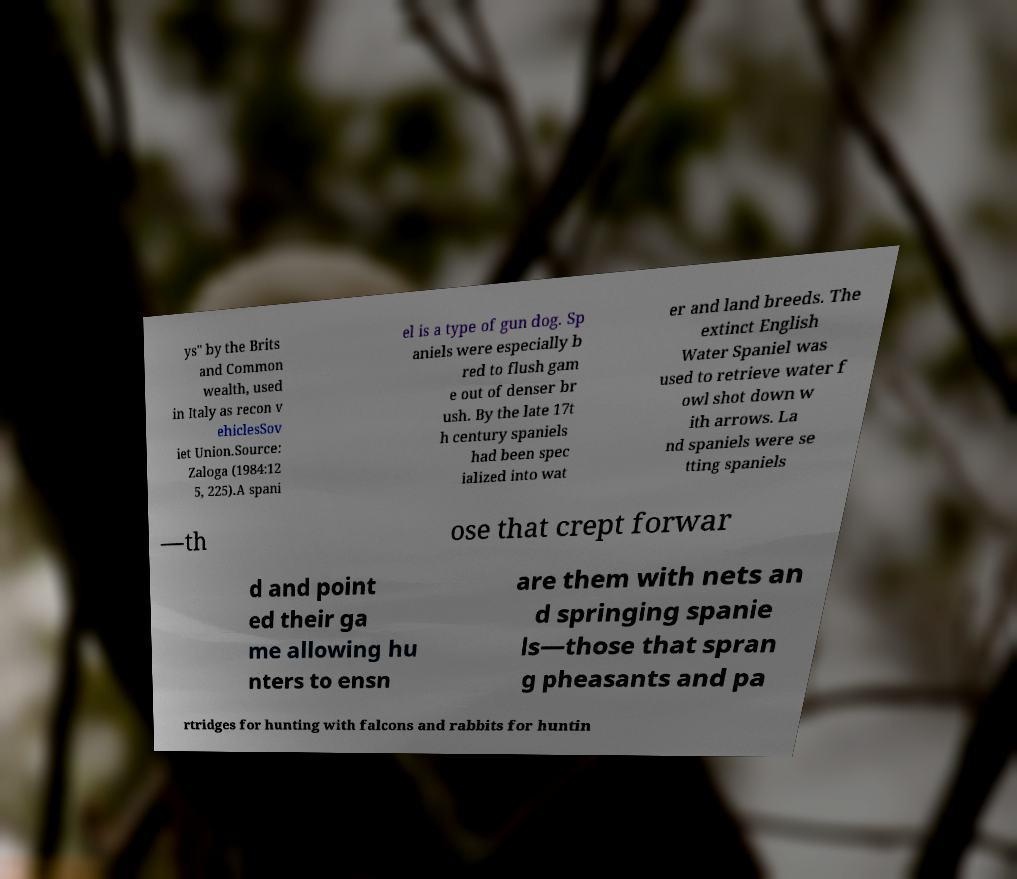I need the written content from this picture converted into text. Can you do that? ys" by the Brits and Common wealth, used in Italy as recon v ehiclesSov iet Union.Source: Zaloga (1984:12 5, 225).A spani el is a type of gun dog. Sp aniels were especially b red to flush gam e out of denser br ush. By the late 17t h century spaniels had been spec ialized into wat er and land breeds. The extinct English Water Spaniel was used to retrieve water f owl shot down w ith arrows. La nd spaniels were se tting spaniels —th ose that crept forwar d and point ed their ga me allowing hu nters to ensn are them with nets an d springing spanie ls—those that spran g pheasants and pa rtridges for hunting with falcons and rabbits for huntin 